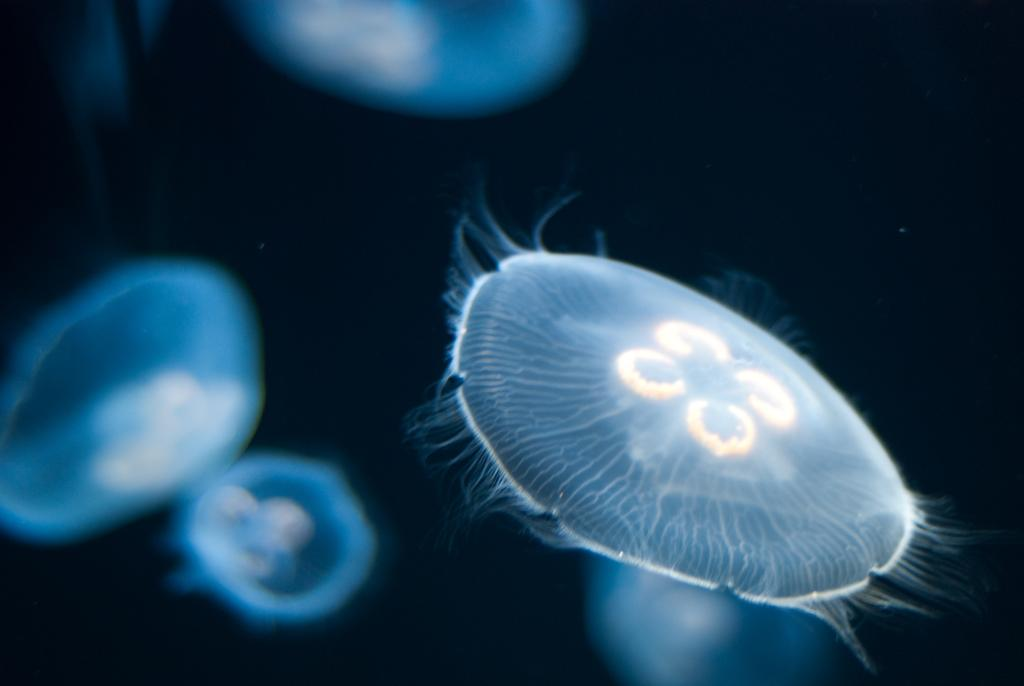What type of sea creatures are visible in the image? There are moon jellyfish in the image. Can you describe any other creatures in the image? There are many fish in the image, but they are blurry. What type of stick can be seen in the image? There is no stick present in the image. How many beads are visible in the image? There are no beads present in the image. 